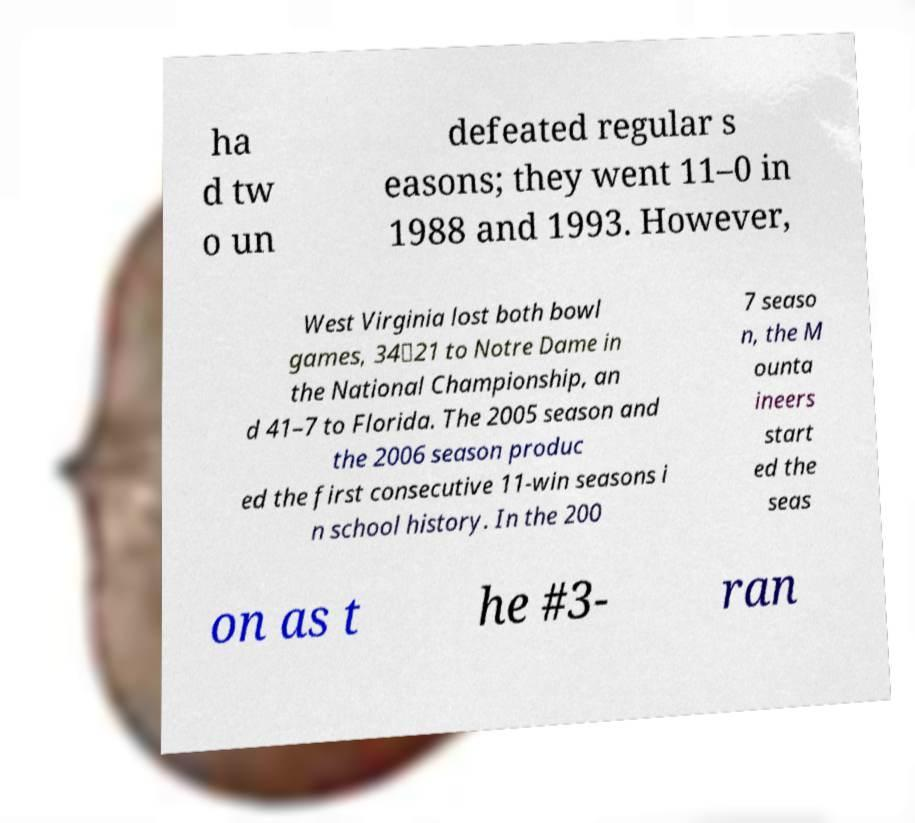I need the written content from this picture converted into text. Can you do that? ha d tw o un defeated regular s easons; they went 11–0 in 1988 and 1993. However, West Virginia lost both bowl games, 34‑21 to Notre Dame in the National Championship, an d 41–7 to Florida. The 2005 season and the 2006 season produc ed the first consecutive 11-win seasons i n school history. In the 200 7 seaso n, the M ounta ineers start ed the seas on as t he #3- ran 